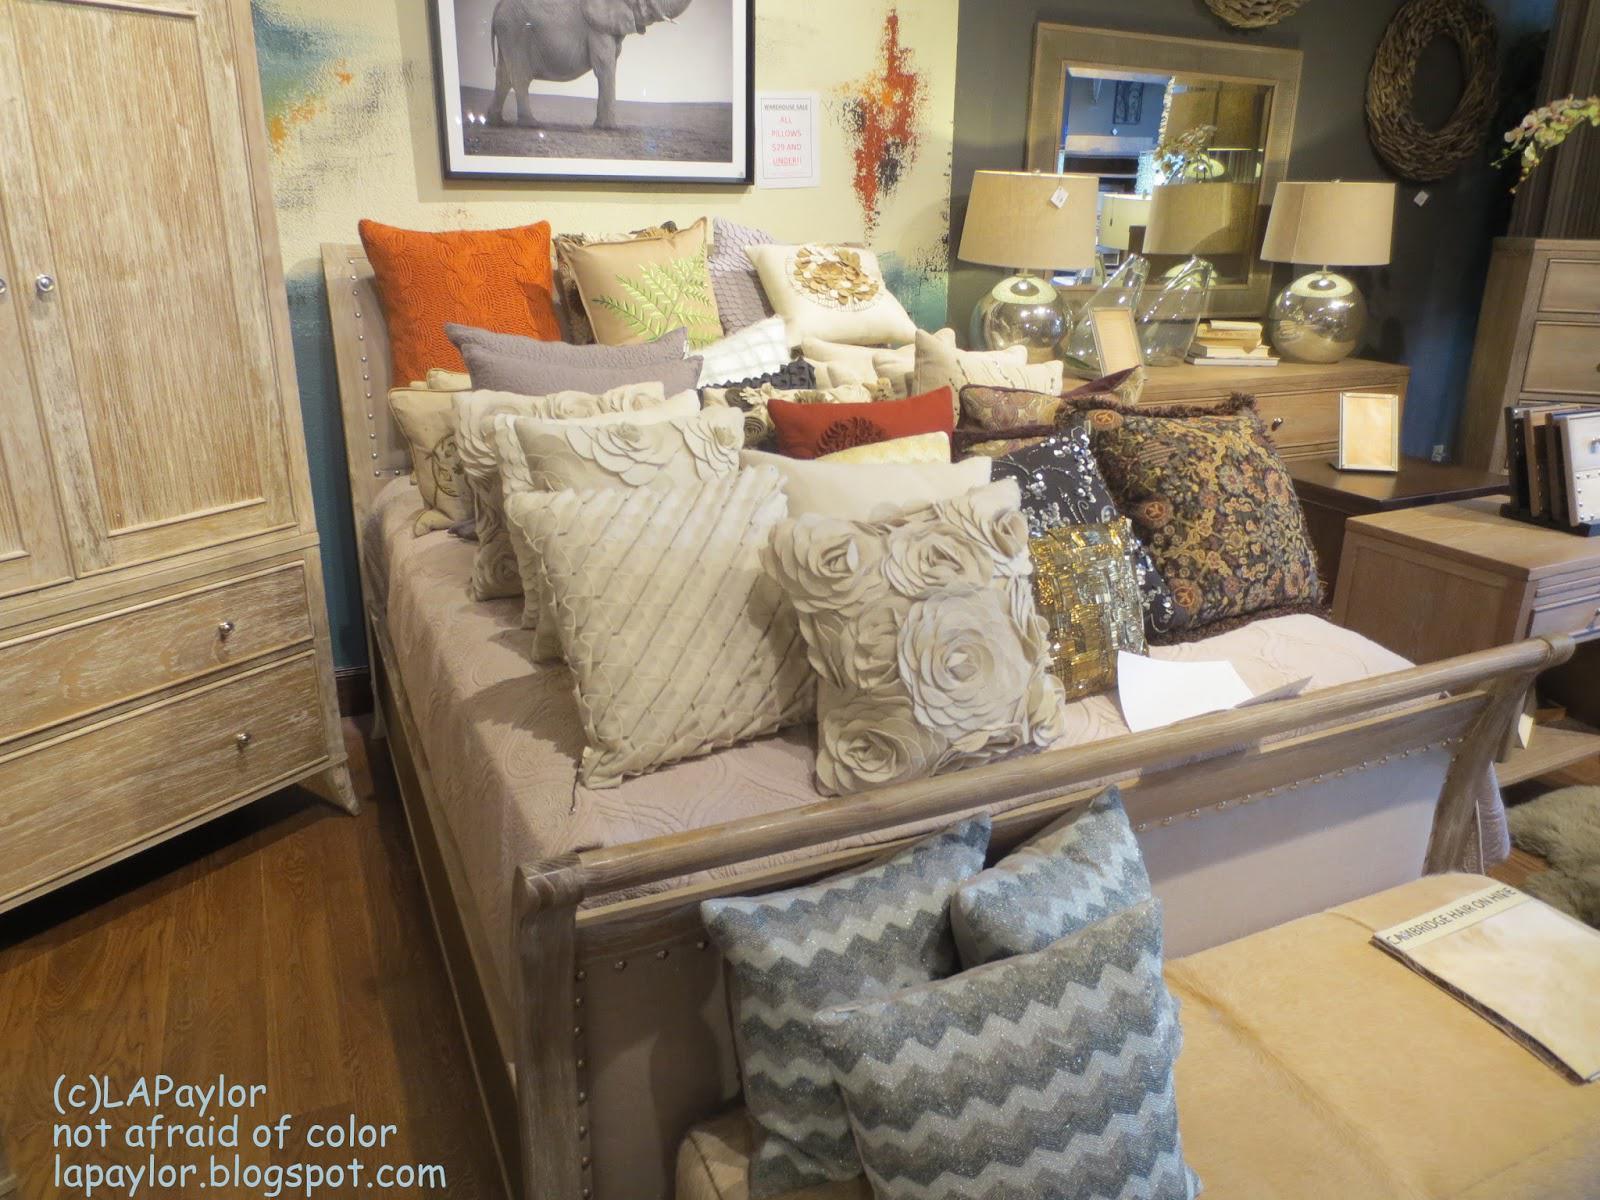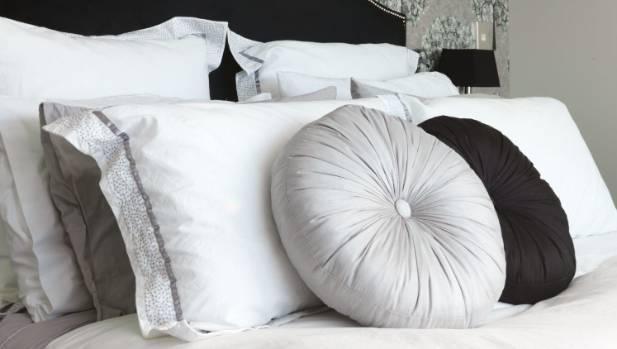The first image is the image on the left, the second image is the image on the right. For the images shown, is this caption "The bed on the farthest right has mostly solid white pillows." true? Answer yes or no. Yes. 